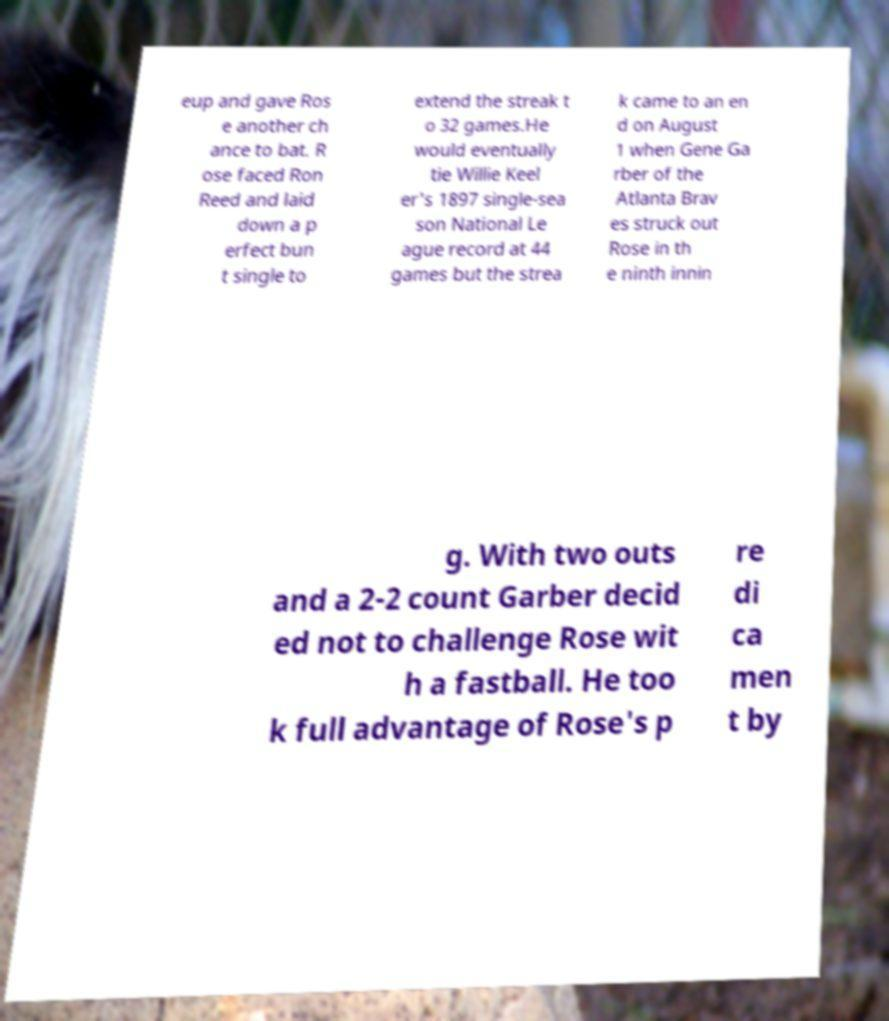Please identify and transcribe the text found in this image. eup and gave Ros e another ch ance to bat. R ose faced Ron Reed and laid down a p erfect bun t single to extend the streak t o 32 games.He would eventually tie Willie Keel er's 1897 single-sea son National Le ague record at 44 games but the strea k came to an en d on August 1 when Gene Ga rber of the Atlanta Brav es struck out Rose in th e ninth innin g. With two outs and a 2-2 count Garber decid ed not to challenge Rose wit h a fastball. He too k full advantage of Rose's p re di ca men t by 